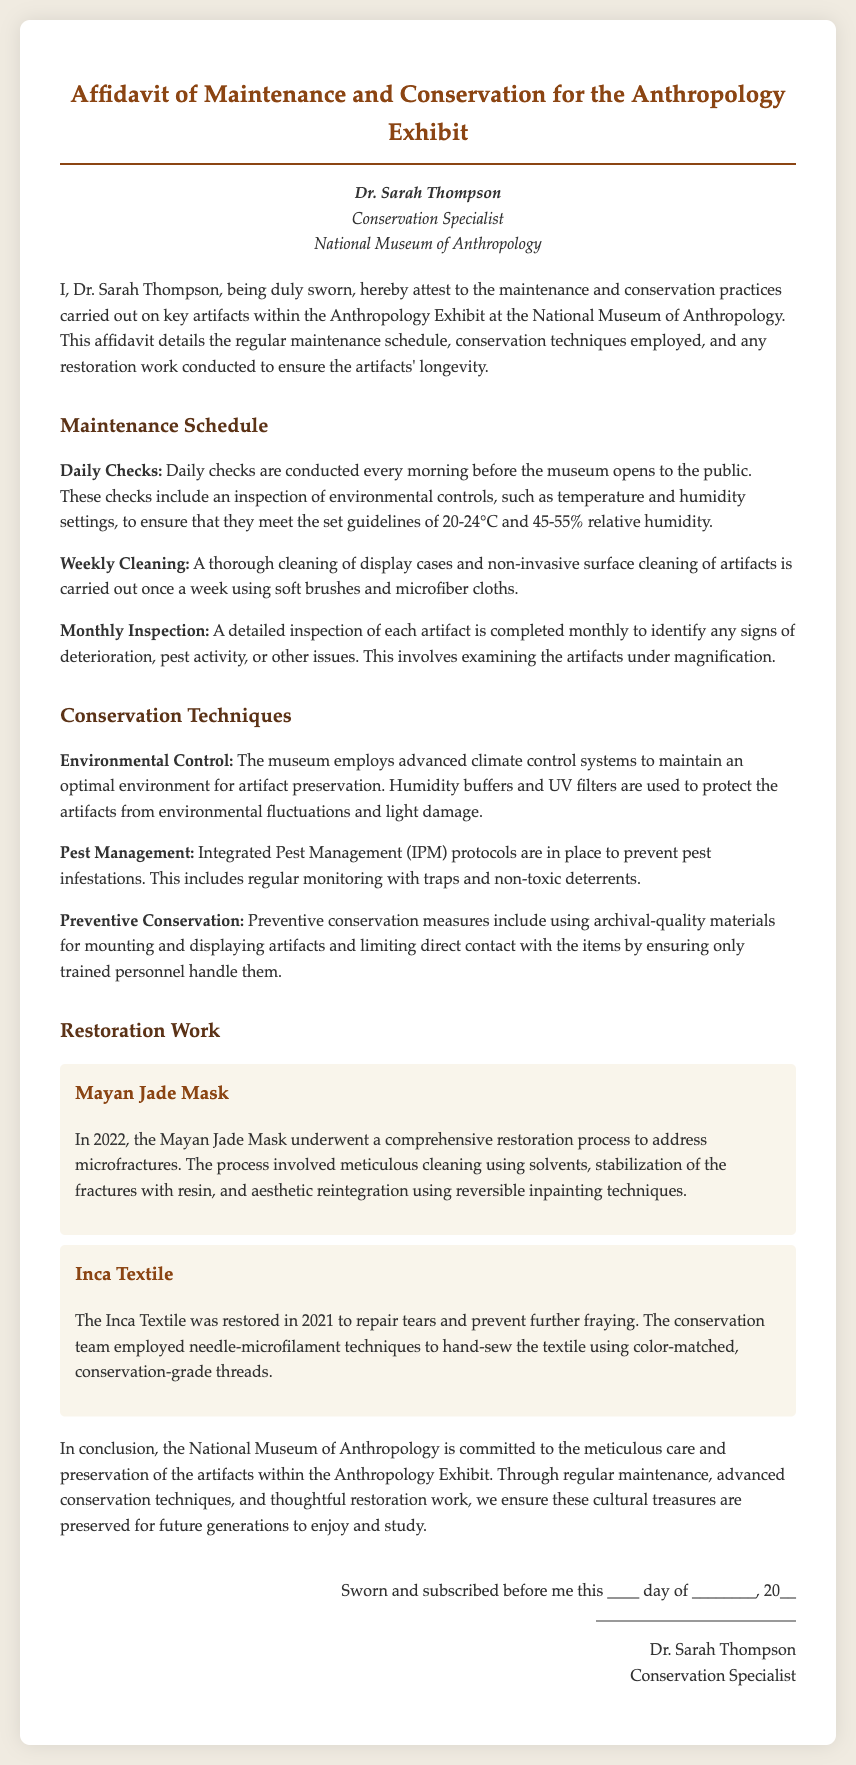What is the name of the conservation specialist? The name of the conservation specialist is mentioned at the beginning of the affidavit.
Answer: Dr. Sarah Thompson What is the optimal temperature range for artifact preservation? The optimal temperature range for artifact preservation is specified in the maintenance schedule.
Answer: 20-24°C How often are daily checks conducted? The frequency of daily checks is detailed in the maintenance schedule section.
Answer: Daily What conservation technique is used to manage pests? The document describes a specific pest management strategy in the conservation techniques section.
Answer: Integrated Pest Management (IPM) When was the restoration of the Mayan Jade Mask completed? The year of completion for the restoration of the Mayan Jade Mask is provided in the restoration work section.
Answer: 2022 What material was used to repair the Inca Textile? The specific type of thread used in the restoration of the Inca Textile is identified in the restoration work section.
Answer: Conservation-grade threads How often is a detailed inspection conducted? The frequency of the detailed inspection is outlined in the maintenance schedule.
Answer: Monthly What is used to protect artifacts from light damage? The document mentions a specific type of system used for this protection in the conservation techniques section.
Answer: UV filters 